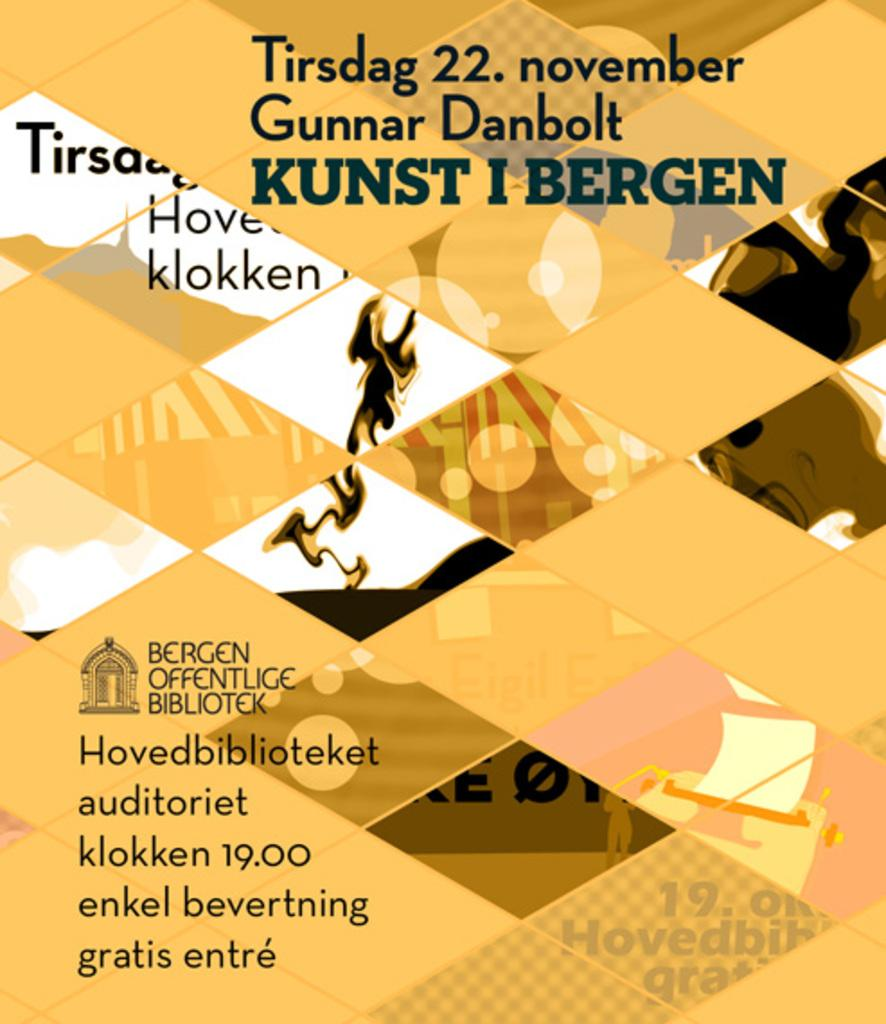<image>
Describe the image concisely. Tirsdag 22. November Gunnar Danbolt Kunst I Bergen poster being shown. 